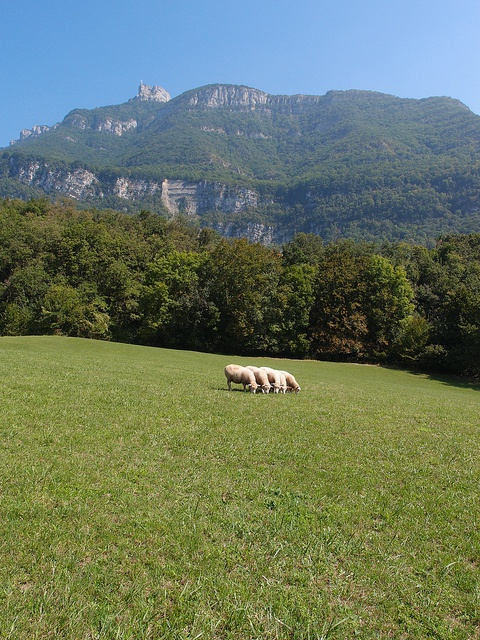Describe the objects in this image and their specific colors. I can see sheep in gray, ivory, black, and tan tones, sheep in gray, ivory, and tan tones, sheep in gray, ivory, tan, and maroon tones, and sheep in gray, ivory, maroon, and tan tones in this image. 